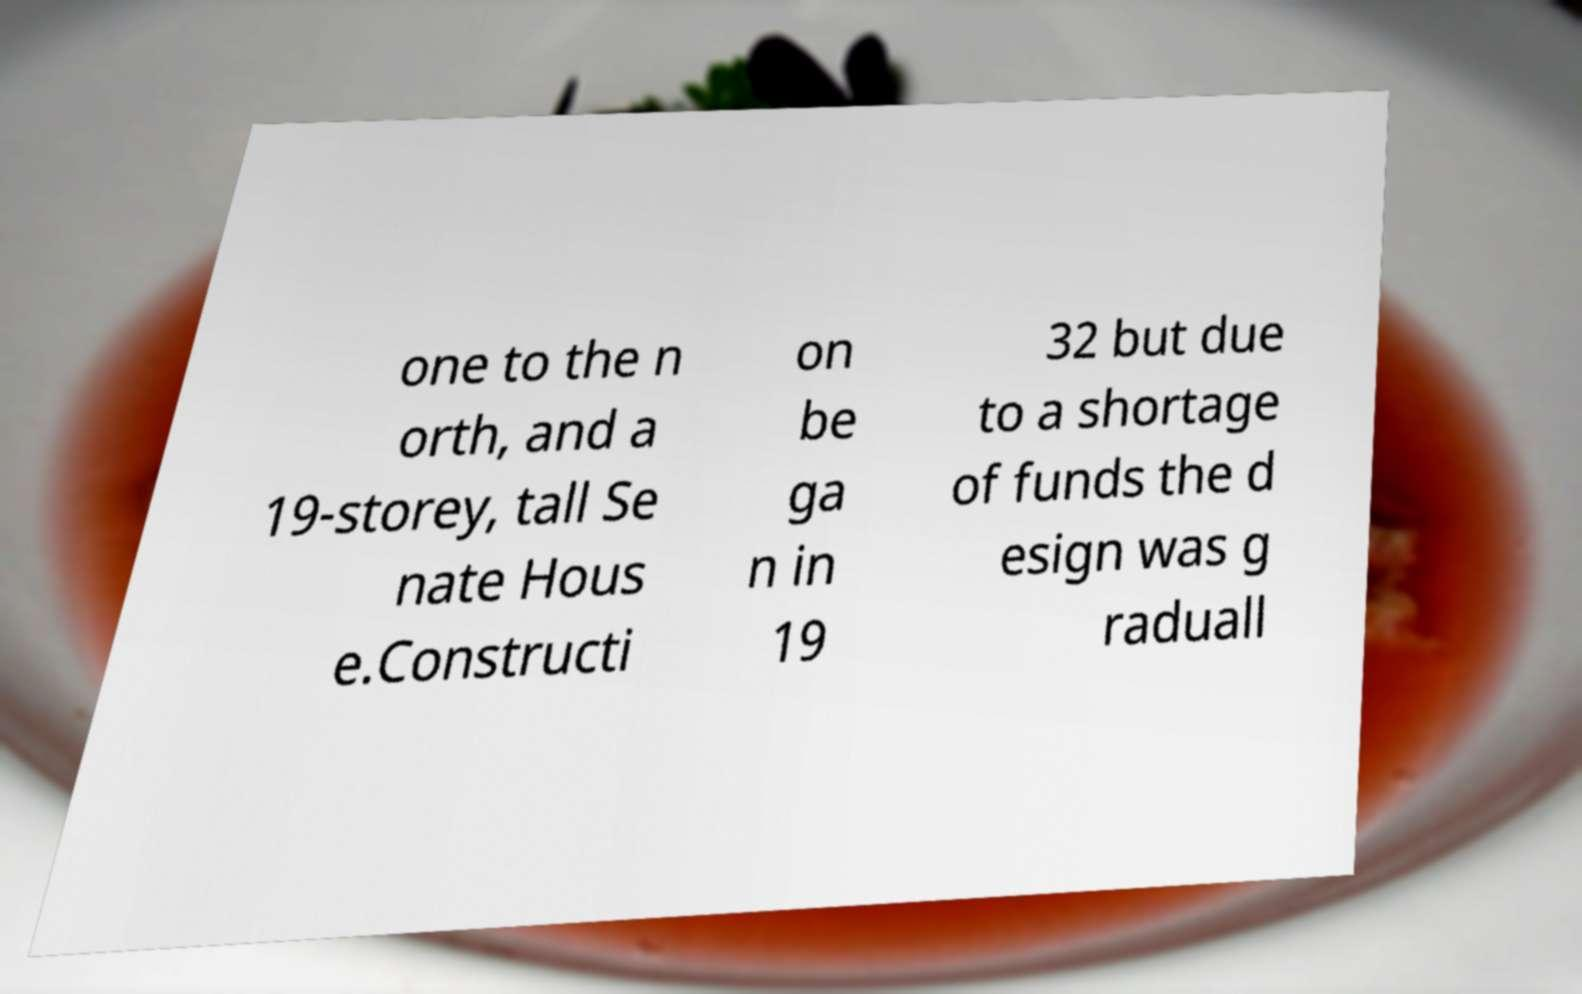Can you accurately transcribe the text from the provided image for me? one to the n orth, and a 19-storey, tall Se nate Hous e.Constructi on be ga n in 19 32 but due to a shortage of funds the d esign was g raduall 